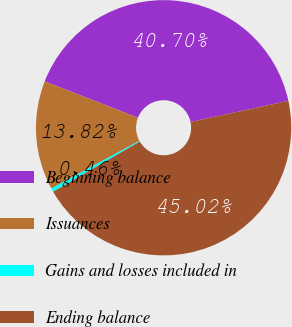<chart> <loc_0><loc_0><loc_500><loc_500><pie_chart><fcel>Beginning balance<fcel>Issuances<fcel>Gains and losses included in<fcel>Ending balance<nl><fcel>40.7%<fcel>13.82%<fcel>0.46%<fcel>45.02%<nl></chart> 